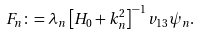<formula> <loc_0><loc_0><loc_500><loc_500>F _ { n } \colon = \lambda _ { n } \left [ H _ { 0 } + k _ { n } ^ { 2 } \right ] ^ { - 1 } v _ { 1 3 } \psi _ { n } .</formula> 